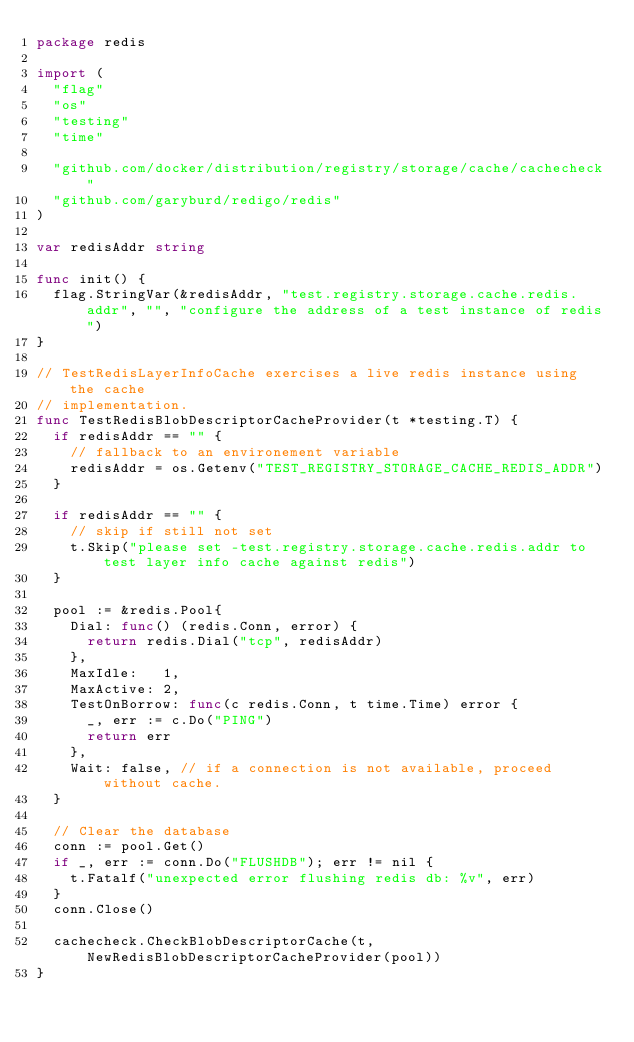Convert code to text. <code><loc_0><loc_0><loc_500><loc_500><_Go_>package redis

import (
	"flag"
	"os"
	"testing"
	"time"

	"github.com/docker/distribution/registry/storage/cache/cachecheck"
	"github.com/garyburd/redigo/redis"
)

var redisAddr string

func init() {
	flag.StringVar(&redisAddr, "test.registry.storage.cache.redis.addr", "", "configure the address of a test instance of redis")
}

// TestRedisLayerInfoCache exercises a live redis instance using the cache
// implementation.
func TestRedisBlobDescriptorCacheProvider(t *testing.T) {
	if redisAddr == "" {
		// fallback to an environement variable
		redisAddr = os.Getenv("TEST_REGISTRY_STORAGE_CACHE_REDIS_ADDR")
	}

	if redisAddr == "" {
		// skip if still not set
		t.Skip("please set -test.registry.storage.cache.redis.addr to test layer info cache against redis")
	}

	pool := &redis.Pool{
		Dial: func() (redis.Conn, error) {
			return redis.Dial("tcp", redisAddr)
		},
		MaxIdle:   1,
		MaxActive: 2,
		TestOnBorrow: func(c redis.Conn, t time.Time) error {
			_, err := c.Do("PING")
			return err
		},
		Wait: false, // if a connection is not available, proceed without cache.
	}

	// Clear the database
	conn := pool.Get()
	if _, err := conn.Do("FLUSHDB"); err != nil {
		t.Fatalf("unexpected error flushing redis db: %v", err)
	}
	conn.Close()

	cachecheck.CheckBlobDescriptorCache(t, NewRedisBlobDescriptorCacheProvider(pool))
}
</code> 